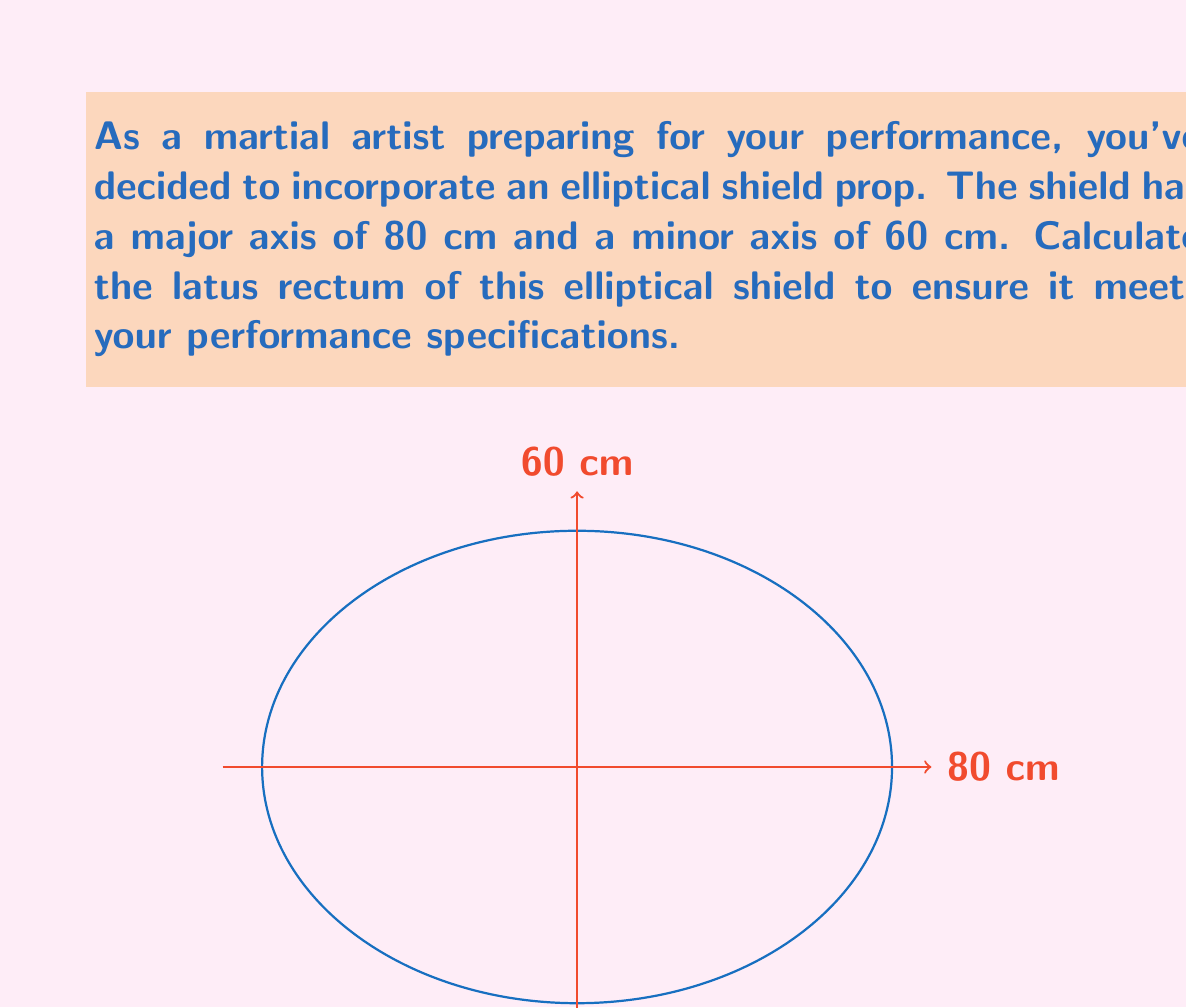What is the answer to this math problem? Let's approach this step-by-step:

1) The latus rectum of an ellipse is the chord that passes through a focus and is perpendicular to the major axis. Its length is given by the formula:

   $$ L = \frac{2b^2}{a} $$

   where $L$ is the latus rectum, $a$ is the semi-major axis, and $b$ is the semi-minor axis.

2) From the given information:
   - Major axis = 80 cm, so $a = 40$ cm
   - Minor axis = 60 cm, so $b = 30$ cm

3) Substituting these values into the formula:

   $$ L = \frac{2(30^2)}{40} $$

4) Simplify:
   $$ L = \frac{2(900)}{40} = \frac{1800}{40} $$

5) Calculate the final result:
   $$ L = 45 \text{ cm} $$

Thus, the latus rectum of your elliptical shield prop is 45 cm.
Answer: 45 cm 